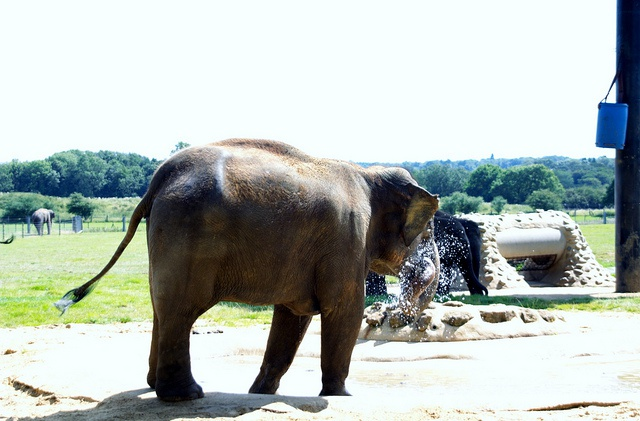Describe the objects in this image and their specific colors. I can see elephant in white, black, ivory, and gray tones, elephant in white, black, navy, darkblue, and gray tones, and elephant in white, lightgray, darkgray, navy, and blue tones in this image. 